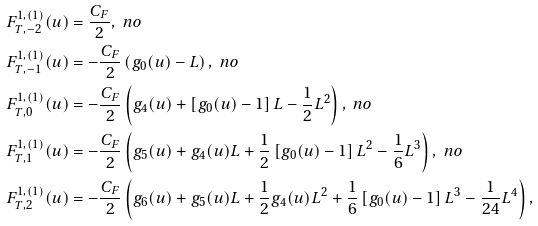Convert formula to latex. <formula><loc_0><loc_0><loc_500><loc_500>F _ { T , - 2 } ^ { 1 , ( 1 ) } ( u ) & = \frac { C _ { F } } { 2 } , \ n o \\ F _ { T , - 1 } ^ { 1 , ( 1 ) } ( u ) & = - \frac { C _ { F } } { 2 } \left ( g _ { 0 } ( u ) - L \right ) , \ n o \\ F _ { T , 0 } ^ { 1 , ( 1 ) } ( u ) & = - \frac { C _ { F } } { 2 } \left ( g _ { 4 } ( u ) + \left [ g _ { 0 } ( u ) - 1 \right ] L - \frac { 1 } { 2 } L ^ { 2 } \right ) , \ n o \\ F _ { T , 1 } ^ { 1 , ( 1 ) } ( u ) & = - \frac { C _ { F } } { 2 } \left ( g _ { 5 } ( u ) + g _ { 4 } ( u ) L + \frac { 1 } { 2 } \left [ g _ { 0 } ( u ) - 1 \right ] L ^ { 2 } - \frac { 1 } { 6 } L ^ { 3 } \right ) , \ n o \\ F _ { T , 2 } ^ { 1 , ( 1 ) } ( u ) & = - \frac { C _ { F } } { 2 } \left ( g _ { 6 } ( u ) + g _ { 5 } ( u ) L + \frac { 1 } { 2 } g _ { 4 } ( u ) L ^ { 2 } + \frac { 1 } { 6 } \left [ g _ { 0 } ( u ) - 1 \right ] L ^ { 3 } - \frac { 1 } { 2 4 } L ^ { 4 } \right ) ,</formula> 